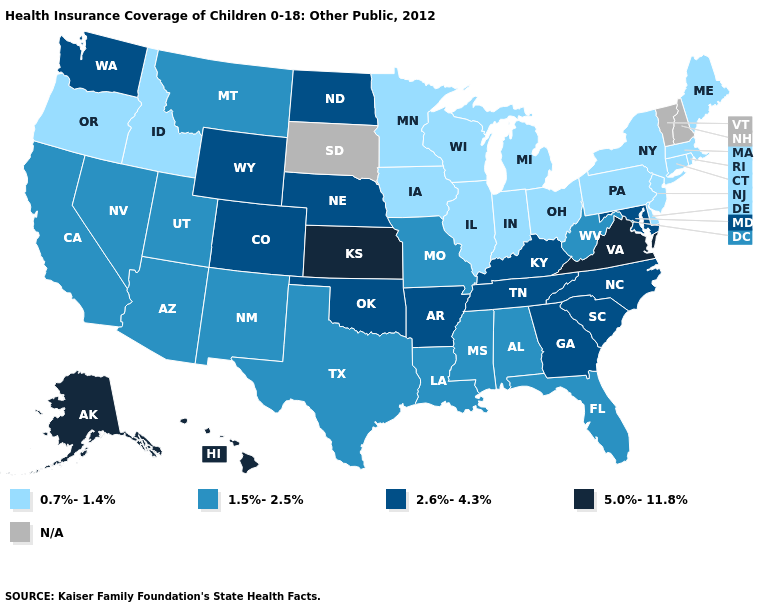Name the states that have a value in the range N/A?
Write a very short answer. New Hampshire, South Dakota, Vermont. What is the lowest value in the USA?
Write a very short answer. 0.7%-1.4%. What is the value of Maryland?
Keep it brief. 2.6%-4.3%. Does Arkansas have the highest value in the South?
Answer briefly. No. Which states have the highest value in the USA?
Answer briefly. Alaska, Hawaii, Kansas, Virginia. Which states have the highest value in the USA?
Quick response, please. Alaska, Hawaii, Kansas, Virginia. What is the value of Connecticut?
Keep it brief. 0.7%-1.4%. Which states have the lowest value in the West?
Concise answer only. Idaho, Oregon. Name the states that have a value in the range 2.6%-4.3%?
Be succinct. Arkansas, Colorado, Georgia, Kentucky, Maryland, Nebraska, North Carolina, North Dakota, Oklahoma, South Carolina, Tennessee, Washington, Wyoming. Which states hav the highest value in the West?
Write a very short answer. Alaska, Hawaii. What is the value of Arizona?
Keep it brief. 1.5%-2.5%. What is the value of Georgia?
Give a very brief answer. 2.6%-4.3%. Name the states that have a value in the range 1.5%-2.5%?
Answer briefly. Alabama, Arizona, California, Florida, Louisiana, Mississippi, Missouri, Montana, Nevada, New Mexico, Texas, Utah, West Virginia. What is the value of Arizona?
Be succinct. 1.5%-2.5%. 